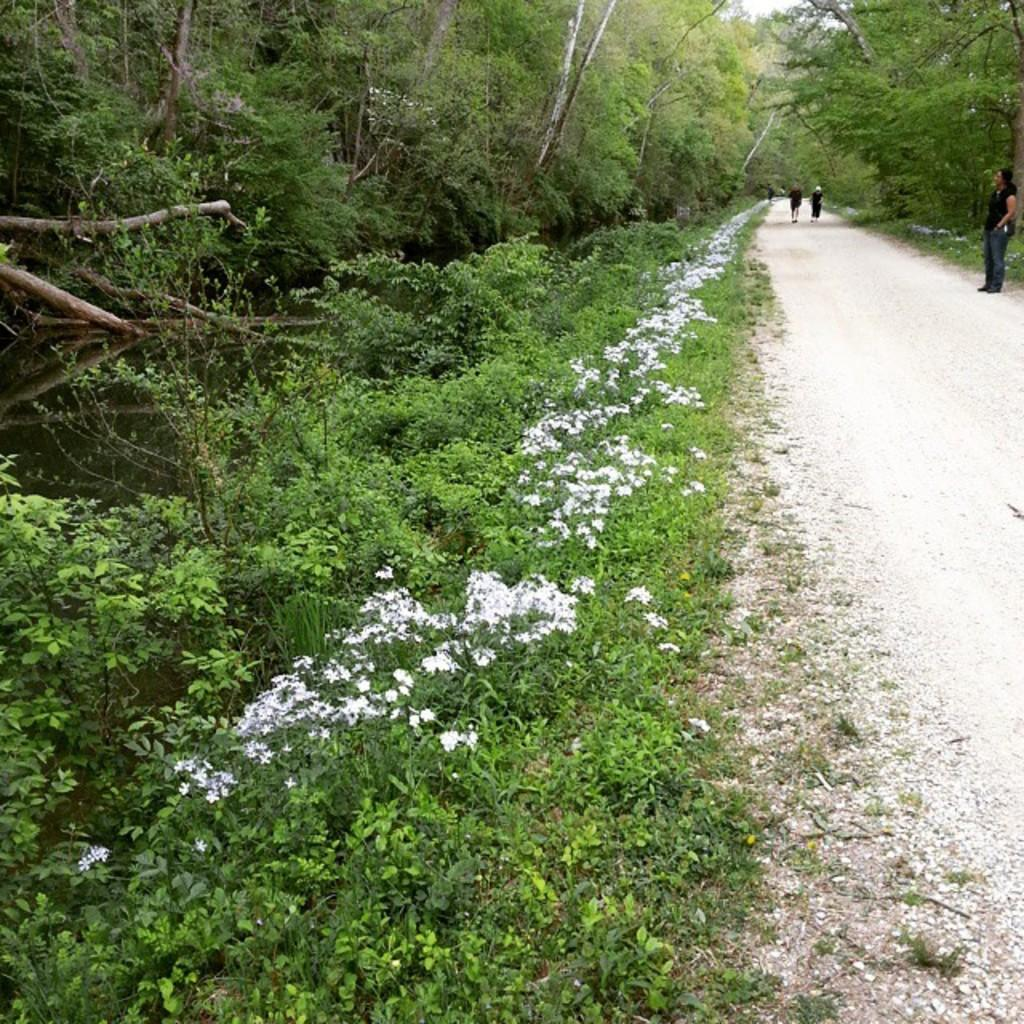What is the setting of the image? The image is an outside view. Can you describe the person in the image? There is a person standing on the road. What are the other people in the image doing? Two persons are running. What type of vegetation can be seen beside the road? There are many flower plants and trees beside the road. What type of doll is sitting on the crib in the image? There is no doll or crib present in the image; it is an outside view with people and vegetation beside the road. 